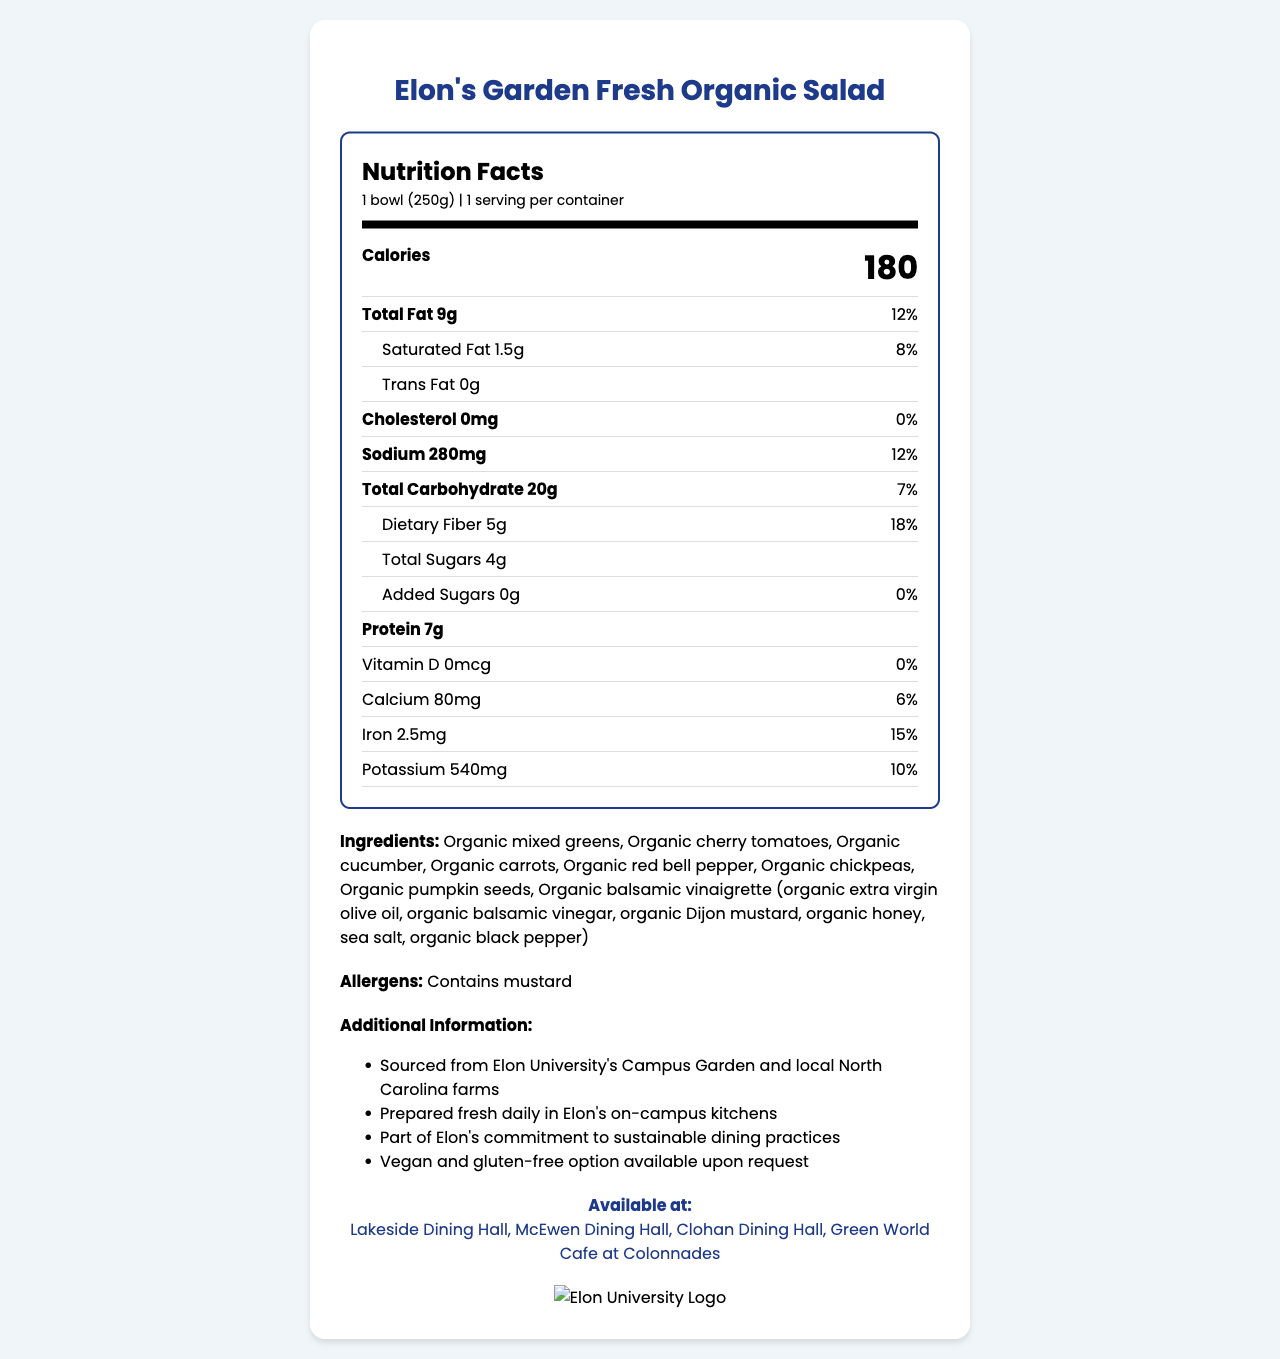what is the serving size of Elon's Garden Fresh Organic Salad? The serving size is indicated in the 'serving info' section at the top of the nutrition label.
Answer: 1 bowl (250g) how many calories are in one serving of the salad? The number of calories is prominently displayed on the nutrition label next to the word 'Calories.'
Answer: 180 what percentage of the daily value for iron does one serving provide? The daily value percentage for iron is listed beside the amount of iron in the nutrients section.
Answer: 15% which dining locations at Elon University offer this salad? The available locations are enumerated in the 'Available at' section near the bottom of the document.
Answer: Lakeside Dining Hall, McEwen Dining Hall, Clohan Dining Hall, Green World Cafe at Colonnades how much protein does one serving of the salad contain? The amount of protein is listed in the nutrients section of the nutrition label.
Answer: 7g what is the main source of fat in the salad? The vinaigrette likely contains extra virgin olive oil, which is a common source of fat in salads.
Answer: Organic balsamic vinaigrette does the salad contain any added sugars? Yes/No The nutrition label shows 0g of added sugars and 0% daily value for added sugars.
Answer: No what is the total amount of carbohydrates per serving? A. 18g B. 20g C. 25g D. 30g 20g of total carbohydrates is listed on the nutrition label in the total carbohydrate section.
Answer: B which of these ingredients are NOT in the salad? I. Organic cucumbers II. Organic croutons III. Organic cherry tomatoes IV. Organic pumpkin seeds Organic croutons are not listed among the ingredients in the document.
Answer: II summarize the main details about Elon's Garden Fresh Organic Salad available at Elon University's campus. The document describes an organic salad available at multiple Elon University dining halls, including its nutritional details, ingredients, allergens, and sourcing information.
Answer: Elon's Garden Fresh Organic Salad is an organic salad containing a mix of greens, vegetables, chickpeas, and pumpkin seeds, served with organic balsamic vinaigrette. A single bowl serving is 250g with 180 calories, 9g total fat, 20g carbohydrates, and 7g protein. It's prepared fresh daily using locally sourced ingredients and is available in multiple on-campus dining locations. is the salad option gluten-free without specific requests? The document mentions that a gluten-free option is available upon request, but it does not specify if the standard option is gluten-free.
Answer: I don't know 